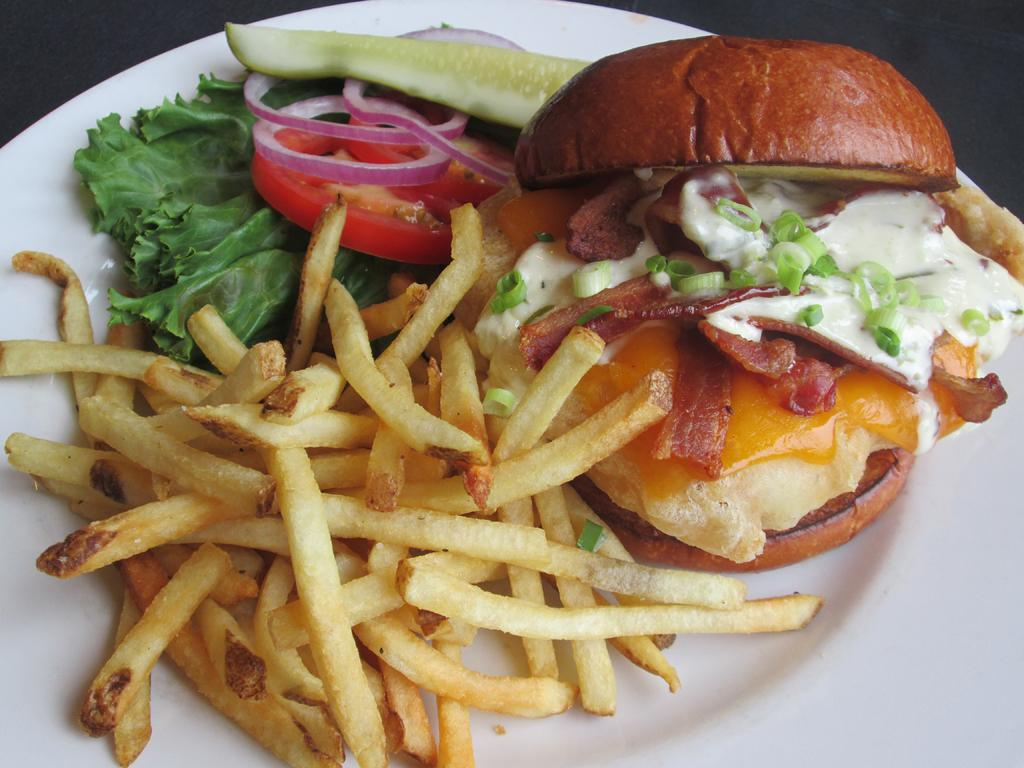What types of food items can be seen in the image? There are food items in the image, but their specific types cannot be determined from the provided facts. What colors are the food items in the image? The food items are in cream, brown, white, red, and green colors. What color is the plate in the image? The plate is in white color. What type of organization is responsible for the circular shape of the food items in the image? There is no mention of any circular shape in the food items in the image, and therefore no organization is responsible for it. 